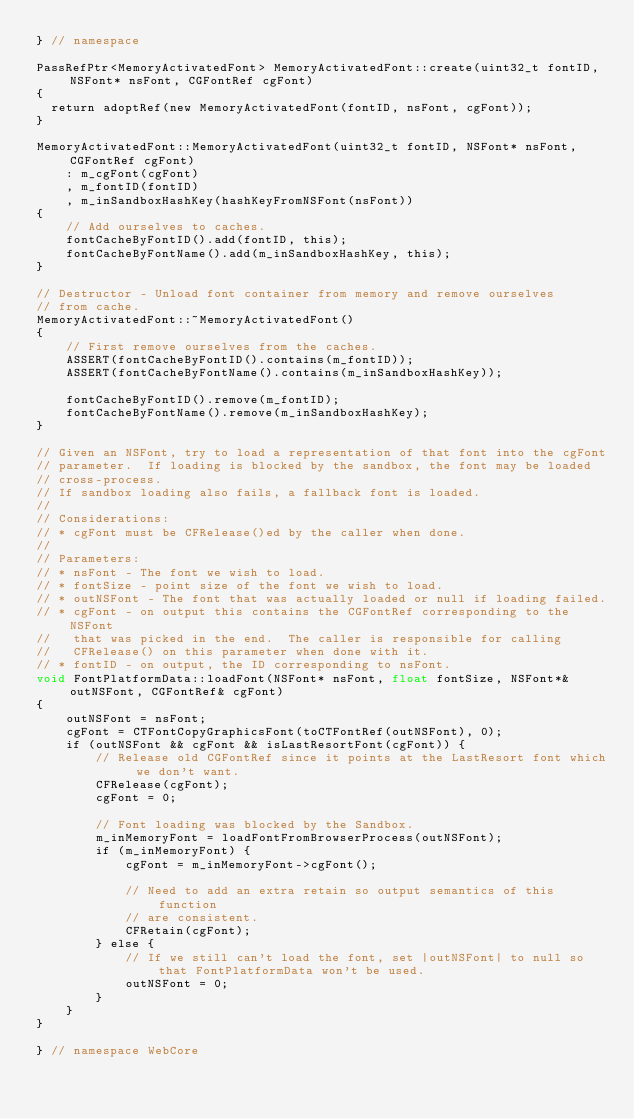Convert code to text. <code><loc_0><loc_0><loc_500><loc_500><_ObjectiveC_>} // namespace

PassRefPtr<MemoryActivatedFont> MemoryActivatedFont::create(uint32_t fontID, NSFont* nsFont, CGFontRef cgFont)
{
  return adoptRef(new MemoryActivatedFont(fontID, nsFont, cgFont));
}

MemoryActivatedFont::MemoryActivatedFont(uint32_t fontID, NSFont* nsFont, CGFontRef cgFont)
    : m_cgFont(cgFont)
    , m_fontID(fontID)
    , m_inSandboxHashKey(hashKeyFromNSFont(nsFont))
{
    // Add ourselves to caches.
    fontCacheByFontID().add(fontID, this);
    fontCacheByFontName().add(m_inSandboxHashKey, this);
}

// Destructor - Unload font container from memory and remove ourselves
// from cache.
MemoryActivatedFont::~MemoryActivatedFont()
{
    // First remove ourselves from the caches.
    ASSERT(fontCacheByFontID().contains(m_fontID));
    ASSERT(fontCacheByFontName().contains(m_inSandboxHashKey));

    fontCacheByFontID().remove(m_fontID);
    fontCacheByFontName().remove(m_inSandboxHashKey);
}

// Given an NSFont, try to load a representation of that font into the cgFont
// parameter.  If loading is blocked by the sandbox, the font may be loaded
// cross-process.
// If sandbox loading also fails, a fallback font is loaded.
//
// Considerations:
// * cgFont must be CFRelease()ed by the caller when done.
//
// Parameters:
// * nsFont - The font we wish to load.
// * fontSize - point size of the font we wish to load.
// * outNSFont - The font that was actually loaded or null if loading failed.
// * cgFont - on output this contains the CGFontRef corresponding to the NSFont
//   that was picked in the end.  The caller is responsible for calling
//   CFRelease() on this parameter when done with it.
// * fontID - on output, the ID corresponding to nsFont.
void FontPlatformData::loadFont(NSFont* nsFont, float fontSize, NSFont*& outNSFont, CGFontRef& cgFont)
{
    outNSFont = nsFont;
    cgFont = CTFontCopyGraphicsFont(toCTFontRef(outNSFont), 0);
    if (outNSFont && cgFont && isLastResortFont(cgFont)) {
        // Release old CGFontRef since it points at the LastResort font which we don't want.
        CFRelease(cgFont);
        cgFont = 0;

        // Font loading was blocked by the Sandbox.
        m_inMemoryFont = loadFontFromBrowserProcess(outNSFont);
        if (m_inMemoryFont) {
            cgFont = m_inMemoryFont->cgFont();

            // Need to add an extra retain so output semantics of this function
            // are consistent.
            CFRetain(cgFont);
        } else {
            // If we still can't load the font, set |outNSFont| to null so that FontPlatformData won't be used.
            outNSFont = 0;
        }
    }
}

} // namespace WebCore
</code> 